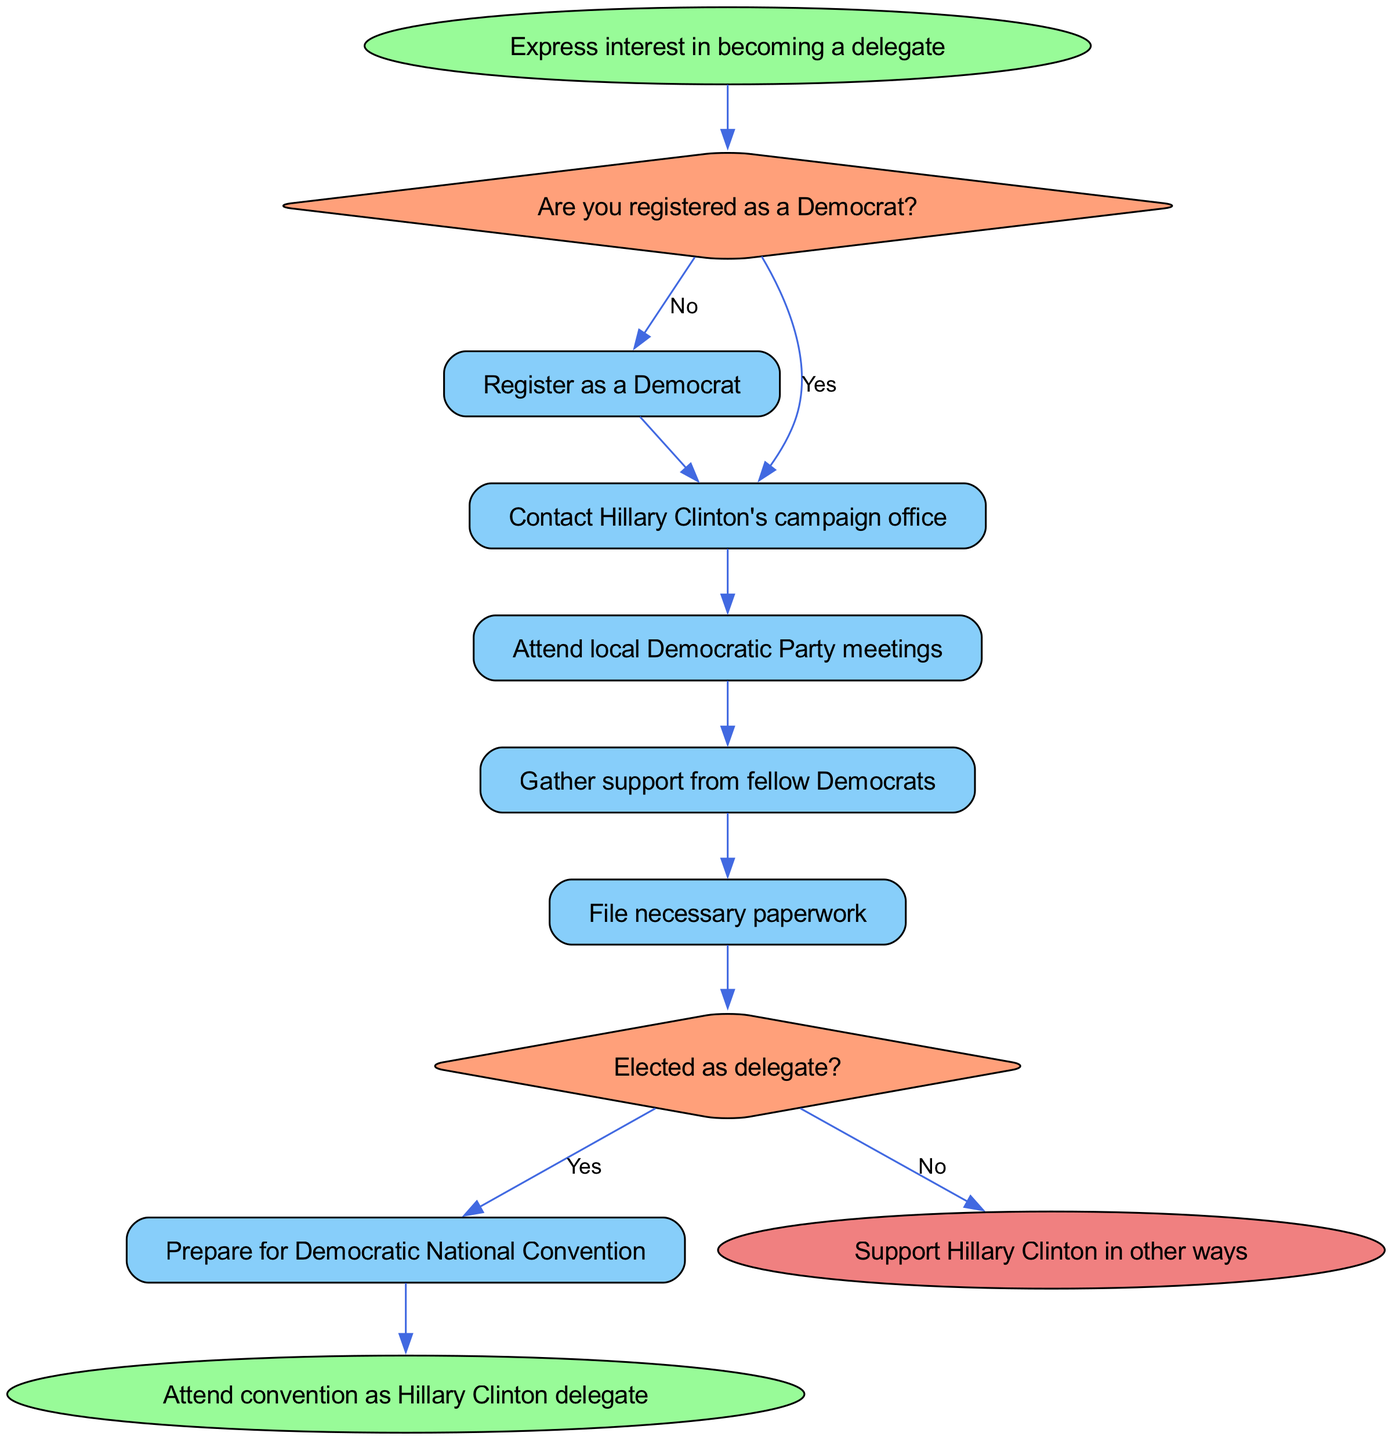What is the starting point in the diagram? The starting point is indicated in the diagram as "Express interest in becoming a delegate."
Answer: Express interest in becoming a delegate How many main action nodes are there? There are six action nodes in the diagram. These are action1 through action6.
Answer: Six What happens if you are not registered as a Democrat? If you are not registered as a Democrat, you have to "Register as a Democrat."
Answer: Register as a Democrat What is the outcome if elected as a delegate? If elected as a delegate, the outcome is to "Prepare for Democratic National Convention."
Answer: Prepare for Democratic National Convention What action follows after attending local Democratic Party meetings? The action that follows is to "Gather support from fellow Democrats."
Answer: Gather support from fellow Democrats What follows "File necessary paperwork" in the sequence? After "File necessary paperwork," the next step is the decision node "Elected as delegate?"
Answer: Elected as delegate? What is the final success outcome of the process? The final success outcome of the process is "Attend convention as Hillary Clinton delegate."
Answer: Attend convention as Hillary Clinton delegate What happens if you answer 'No' to being elected as delegate? If you answer 'No' to being elected as delegate, the outcome is to "Support Hillary Clinton in other ways."
Answer: Support Hillary Clinton in other ways Is there a decision point before filing necessary paperwork? Yes, there is a decision point called "Elected as delegate?" before filing necessary paperwork.
Answer: Yes 